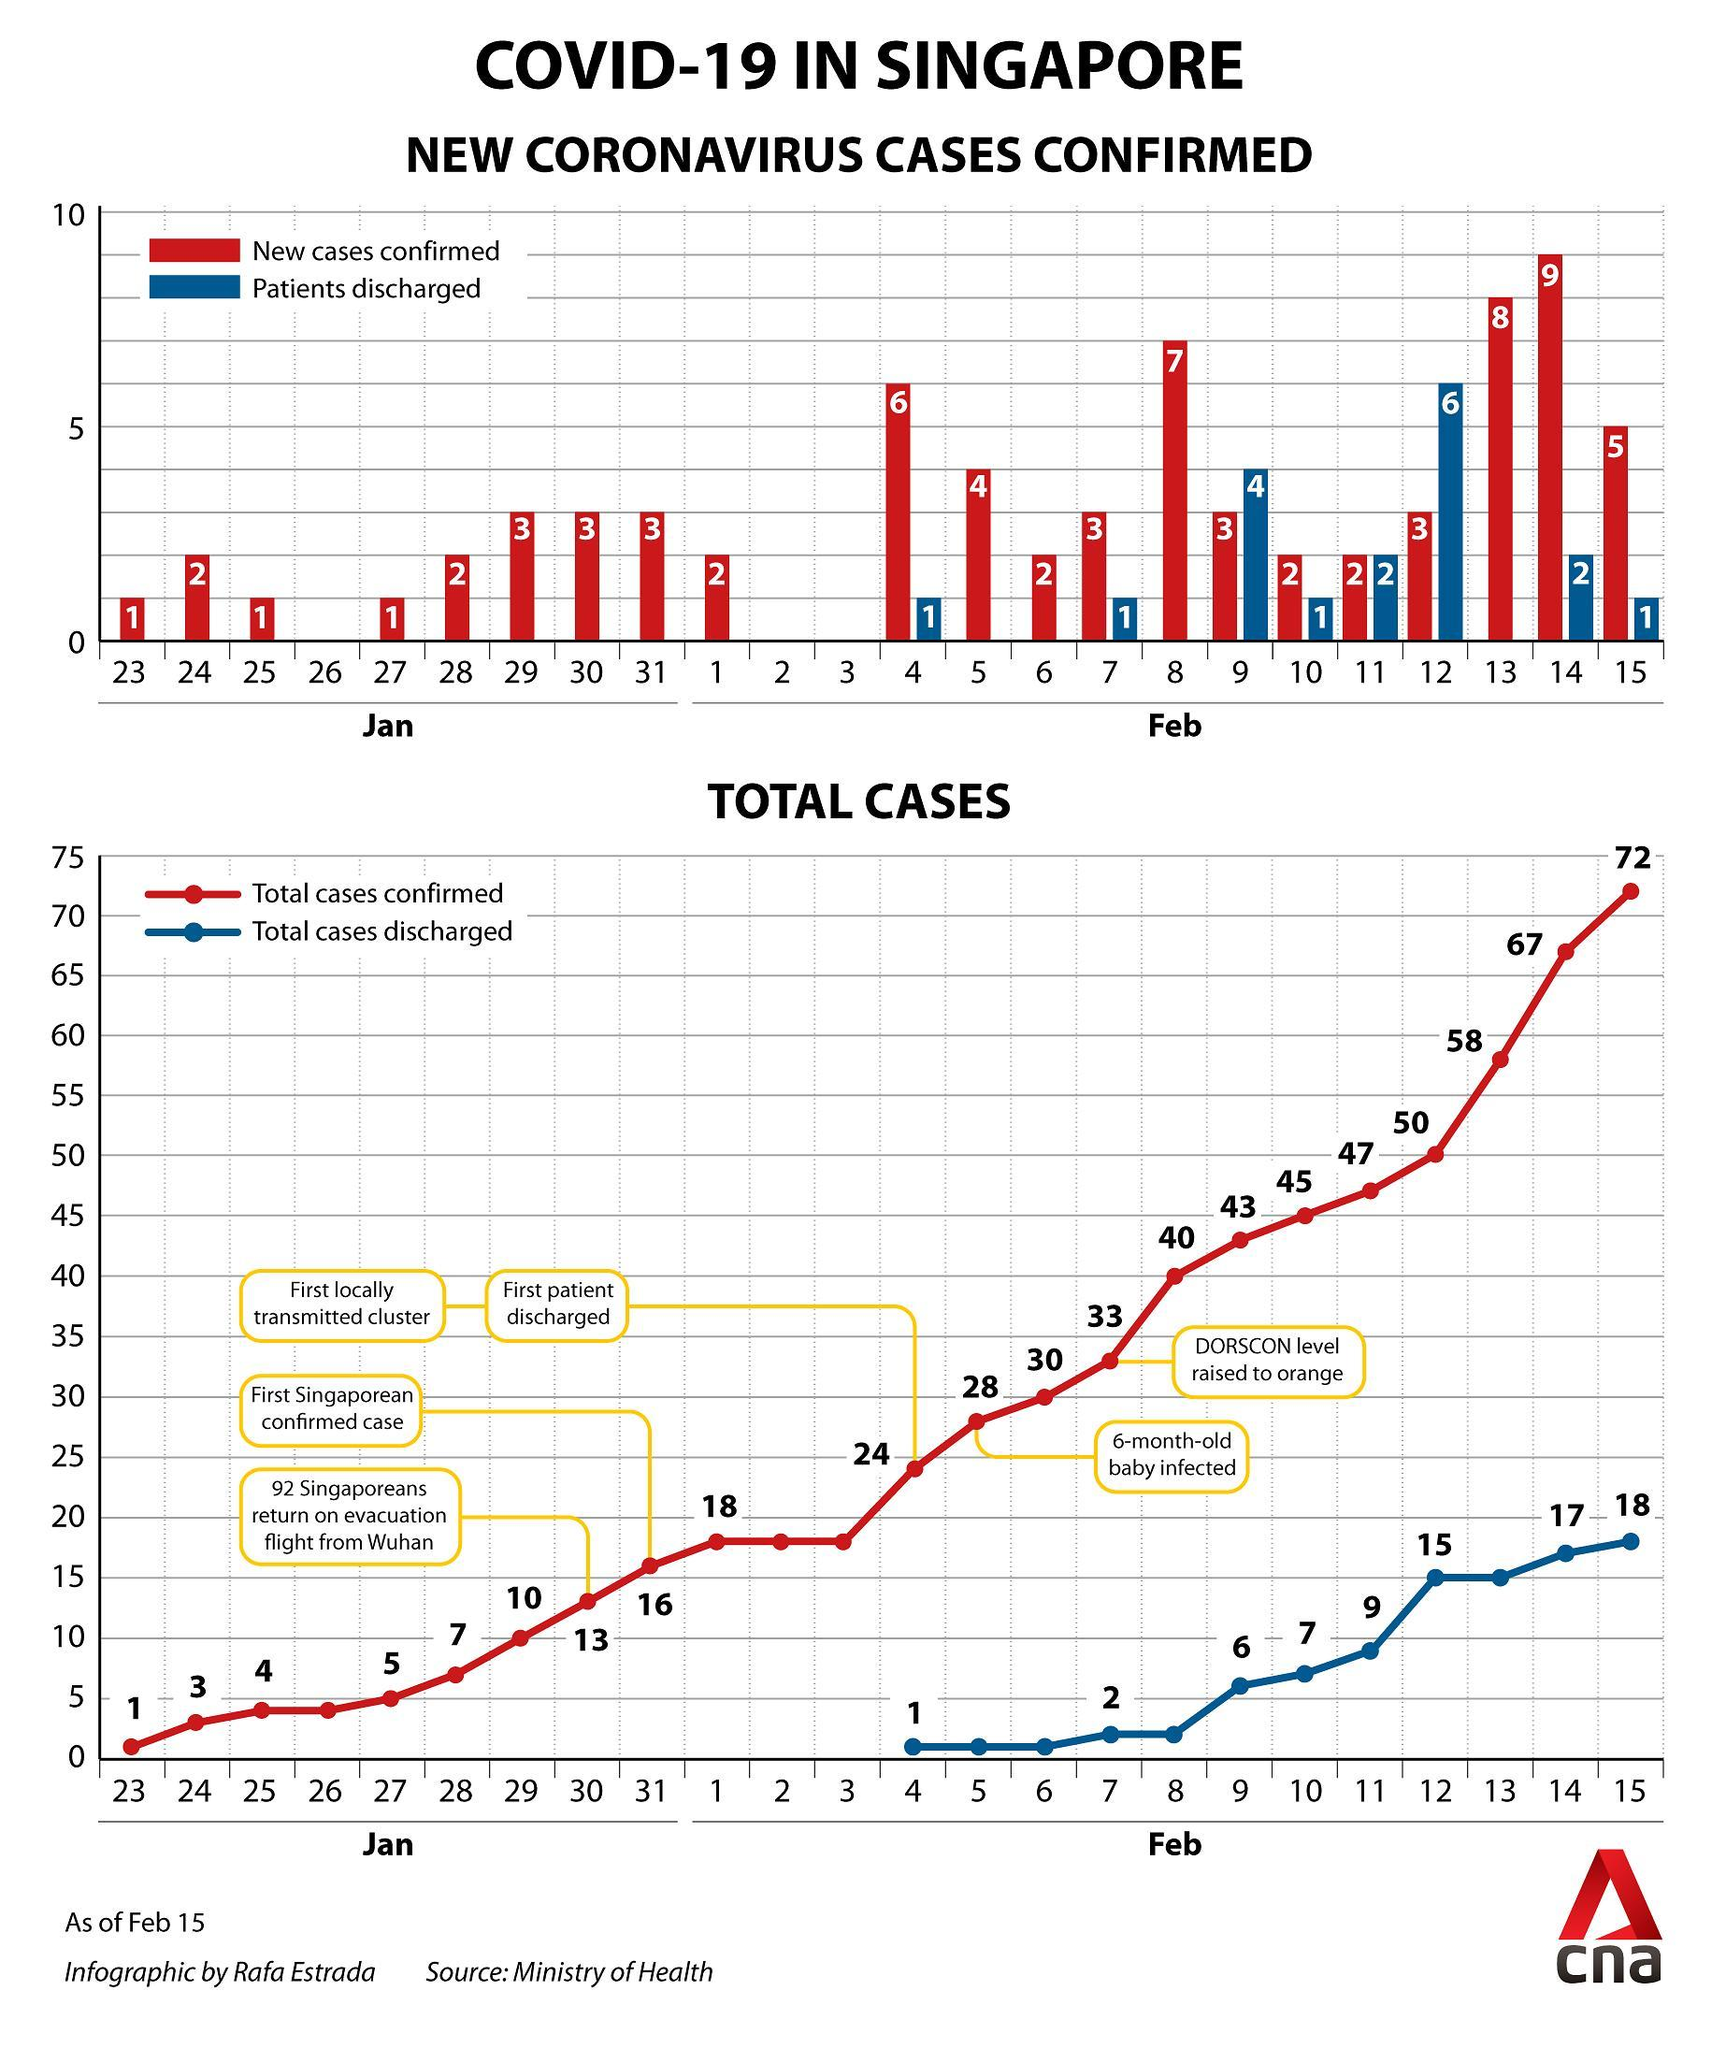How many new COVID-19 cases were confirmed in Singapore as on January 24?
Answer the question with a short phrase. 2 How many new COVID-19 cases were confirmed in Singapore as on January 30? 3 How many COVID-19 patients were discharged from the Singapore hospitals as on February 9? 4 How many COVID-19 patients were discharged from the Singapore hospitals as on February 12? 6 What is the the total number of discharged COVID-19 cases in Singapore as of February 15? 18 What is the the total number of discharged COVID-19 cases in Singapore as of February 14? 17 How many new COVID-19 cases were confirmed in Singapore as on February 13? 8 What is the the total number of confirmed COVID-19 cases reported in Singapore as of February 15? 72 How many COVID-19 patients were discharged from the Singapore hospitals as on February 4? 1 What is the the total number of confirmed COVID-19 cases reported in Singapore as of February 13? 58 